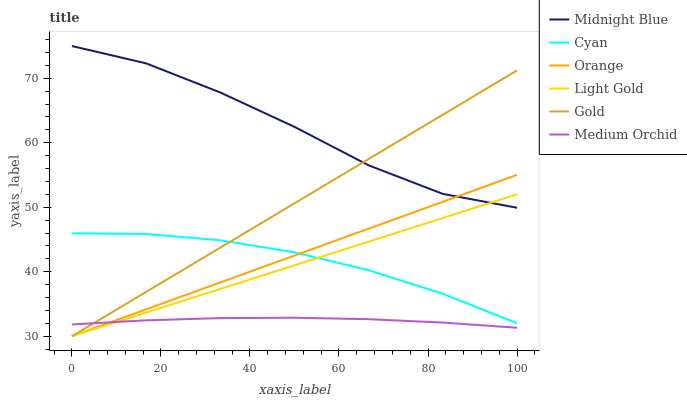Does Medium Orchid have the minimum area under the curve?
Answer yes or no. Yes. Does Midnight Blue have the maximum area under the curve?
Answer yes or no. Yes. Does Gold have the minimum area under the curve?
Answer yes or no. No. Does Gold have the maximum area under the curve?
Answer yes or no. No. Is Light Gold the smoothest?
Answer yes or no. Yes. Is Midnight Blue the roughest?
Answer yes or no. Yes. Is Gold the smoothest?
Answer yes or no. No. Is Gold the roughest?
Answer yes or no. No. Does Medium Orchid have the lowest value?
Answer yes or no. No. Does Midnight Blue have the highest value?
Answer yes or no. Yes. Does Gold have the highest value?
Answer yes or no. No. Is Medium Orchid less than Midnight Blue?
Answer yes or no. Yes. Is Midnight Blue greater than Medium Orchid?
Answer yes or no. Yes. Does Medium Orchid intersect Midnight Blue?
Answer yes or no. No. 